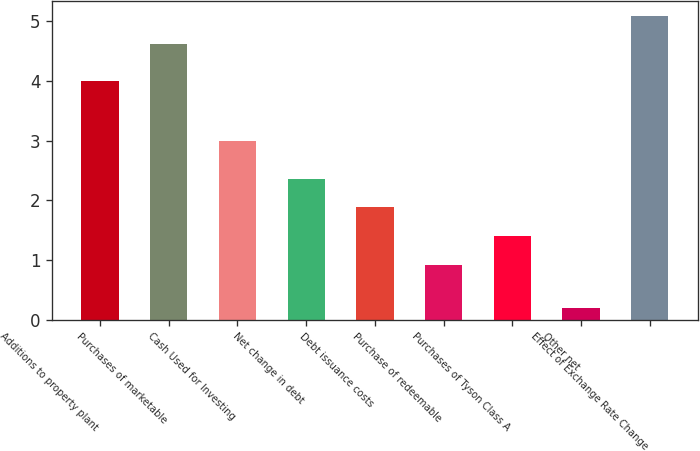<chart> <loc_0><loc_0><loc_500><loc_500><bar_chart><fcel>Additions to property plant<fcel>Purchases of marketable<fcel>Cash Used for Investing<fcel>Net change in debt<fcel>Debt issuance costs<fcel>Purchase of redeemable<fcel>Purchases of Tyson Class A<fcel>Other net<fcel>Effect of Exchange Rate Change<nl><fcel>3.99<fcel>4.61<fcel>3<fcel>2.36<fcel>1.88<fcel>0.92<fcel>1.4<fcel>0.2<fcel>5.09<nl></chart> 